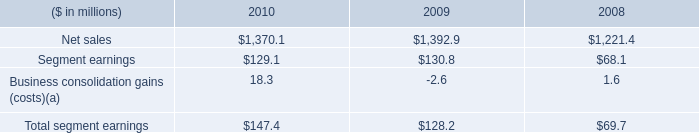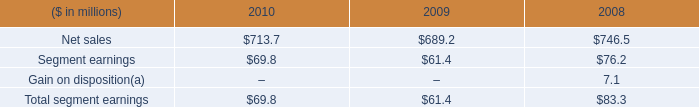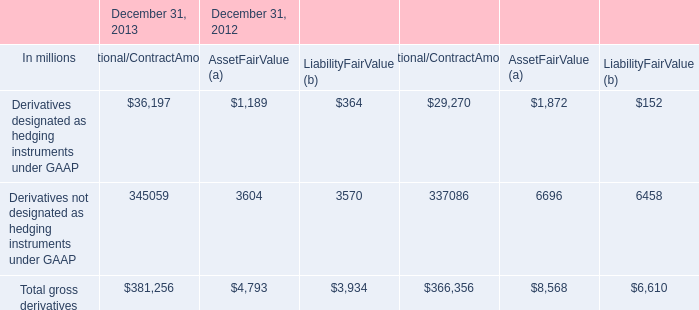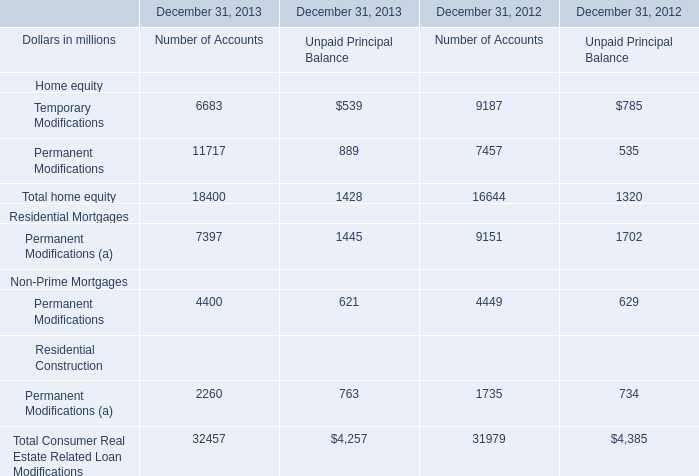In the section with the most Temporary Modifications, what is the growth rate of Permanent Modifications for Number of Accounts ? 
Computations: ((11717 - 7457) / 7457)
Answer: 0.57128. 